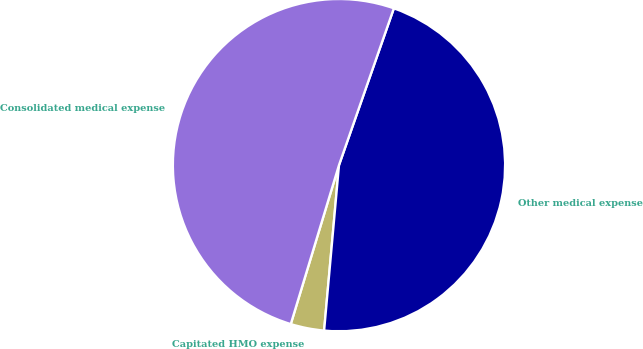Convert chart to OTSL. <chart><loc_0><loc_0><loc_500><loc_500><pie_chart><fcel>Capitated HMO expense<fcel>Other medical expense<fcel>Consolidated medical expense<nl><fcel>3.26%<fcel>46.07%<fcel>50.67%<nl></chart> 